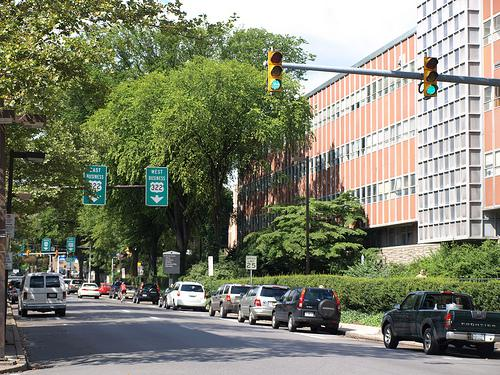Question: where is this scene?
Choices:
A. Country.
B. Mountains.
C. City street.
D. Lake.
Answer with the letter. Answer: C Question: what are these?
Choices:
A. Trucks.
B. Cars.
C. Bikes.
D. Buses.
Answer with the letter. Answer: B Question: what color are the trees?
Choices:
A. Gray.
B. Green.
C. White.
D. Brown.
Answer with the letter. Answer: B 